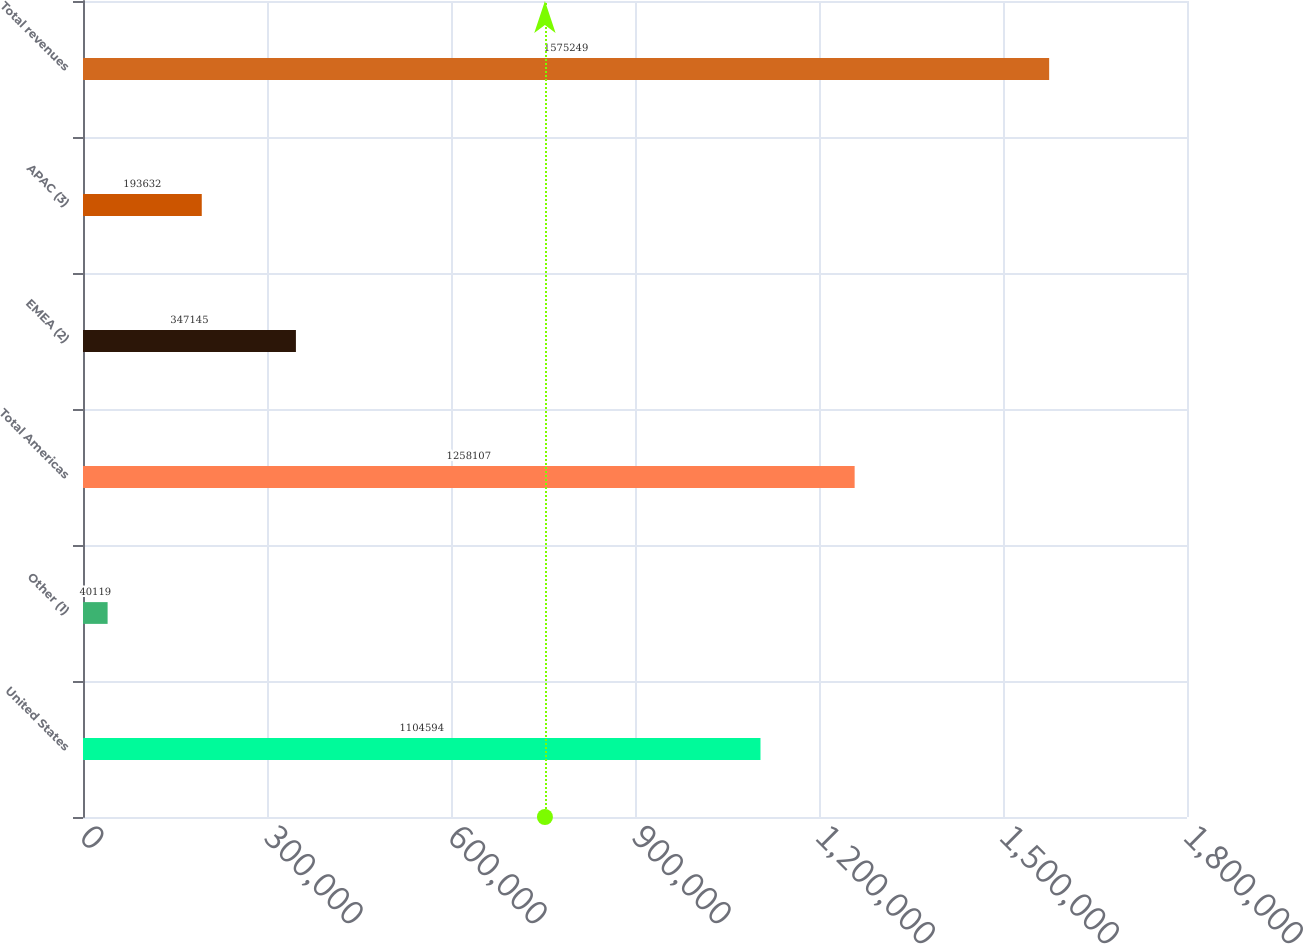<chart> <loc_0><loc_0><loc_500><loc_500><bar_chart><fcel>United States<fcel>Other (1)<fcel>Total Americas<fcel>EMEA (2)<fcel>APAC (3)<fcel>Total revenues<nl><fcel>1.10459e+06<fcel>40119<fcel>1.25811e+06<fcel>347145<fcel>193632<fcel>1.57525e+06<nl></chart> 